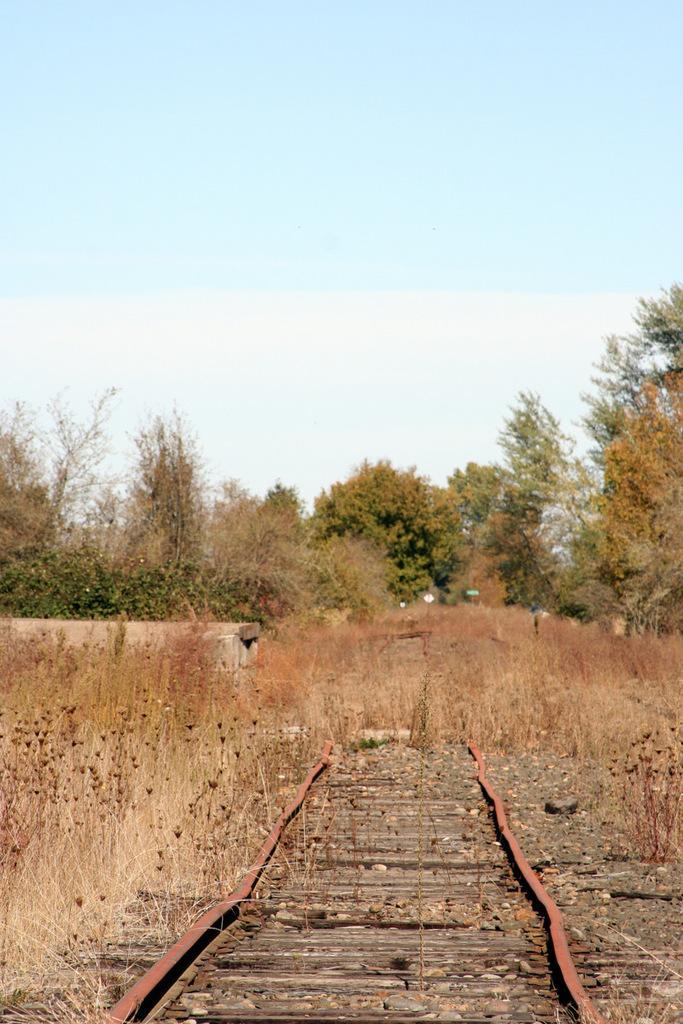How would you summarize this image in a sentence or two? In this image we can see some plants, trees, stones, poles with boards and a track, in the background we can see the sky. 